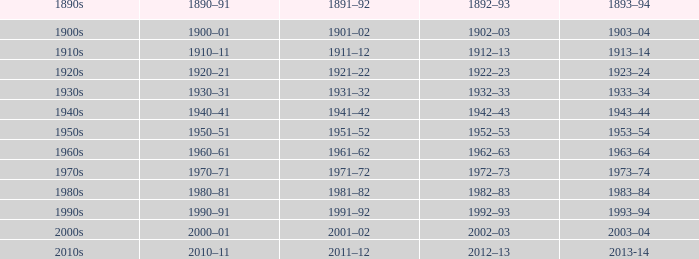What is the year from 1891-92 from the years 1890s to the 1960s? 1961–62. I'm looking to parse the entire table for insights. Could you assist me with that? {'header': ['1890s', '1890–91', '1891–92', '1892–93', '1893–94'], 'rows': [['1900s', '1900–01', '1901–02', '1902–03', '1903–04'], ['1910s', '1910–11', '1911–12', '1912–13', '1913–14'], ['1920s', '1920–21', '1921–22', '1922–23', '1923–24'], ['1930s', '1930–31', '1931–32', '1932–33', '1933–34'], ['1940s', '1940–41', '1941–42', '1942–43', '1943–44'], ['1950s', '1950–51', '1951–52', '1952–53', '1953–54'], ['1960s', '1960–61', '1961–62', '1962–63', '1963–64'], ['1970s', '1970–71', '1971–72', '1972–73', '1973–74'], ['1980s', '1980–81', '1981–82', '1982–83', '1983–84'], ['1990s', '1990–91', '1991–92', '1992–93', '1993–94'], ['2000s', '2000–01', '2001–02', '2002–03', '2003–04'], ['2010s', '2010–11', '2011–12', '2012–13', '2013-14']]} 